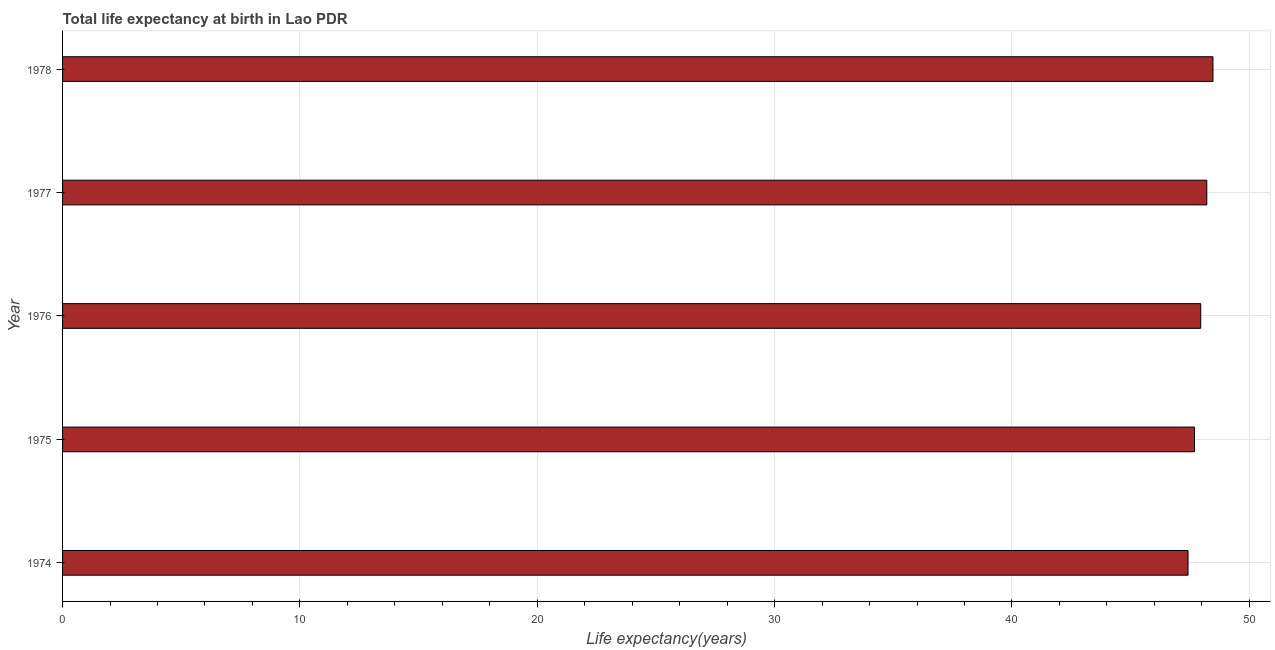What is the title of the graph?
Offer a very short reply. Total life expectancy at birth in Lao PDR. What is the label or title of the X-axis?
Make the answer very short. Life expectancy(years). What is the label or title of the Y-axis?
Your answer should be compact. Year. What is the life expectancy at birth in 1978?
Make the answer very short. 48.47. Across all years, what is the maximum life expectancy at birth?
Ensure brevity in your answer.  48.47. Across all years, what is the minimum life expectancy at birth?
Ensure brevity in your answer.  47.42. In which year was the life expectancy at birth maximum?
Your response must be concise. 1978. In which year was the life expectancy at birth minimum?
Provide a succinct answer. 1974. What is the sum of the life expectancy at birth?
Give a very brief answer. 239.73. What is the difference between the life expectancy at birth in 1974 and 1976?
Your response must be concise. -0.53. What is the average life expectancy at birth per year?
Offer a terse response. 47.95. What is the median life expectancy at birth?
Provide a short and direct response. 47.95. Is the life expectancy at birth in 1976 less than that in 1978?
Offer a terse response. Yes. Is the difference between the life expectancy at birth in 1976 and 1977 greater than the difference between any two years?
Your answer should be compact. No. What is the difference between the highest and the second highest life expectancy at birth?
Provide a short and direct response. 0.26. In how many years, is the life expectancy at birth greater than the average life expectancy at birth taken over all years?
Your answer should be very brief. 3. Are all the bars in the graph horizontal?
Offer a very short reply. Yes. How many years are there in the graph?
Make the answer very short. 5. Are the values on the major ticks of X-axis written in scientific E-notation?
Give a very brief answer. No. What is the Life expectancy(years) in 1974?
Offer a terse response. 47.42. What is the Life expectancy(years) of 1975?
Offer a terse response. 47.69. What is the Life expectancy(years) in 1976?
Offer a very short reply. 47.95. What is the Life expectancy(years) of 1977?
Your response must be concise. 48.21. What is the Life expectancy(years) in 1978?
Keep it short and to the point. 48.47. What is the difference between the Life expectancy(years) in 1974 and 1975?
Offer a terse response. -0.27. What is the difference between the Life expectancy(years) in 1974 and 1976?
Offer a terse response. -0.53. What is the difference between the Life expectancy(years) in 1974 and 1977?
Make the answer very short. -0.79. What is the difference between the Life expectancy(years) in 1974 and 1978?
Provide a short and direct response. -1.05. What is the difference between the Life expectancy(years) in 1975 and 1976?
Offer a terse response. -0.26. What is the difference between the Life expectancy(years) in 1975 and 1977?
Give a very brief answer. -0.52. What is the difference between the Life expectancy(years) in 1975 and 1978?
Keep it short and to the point. -0.78. What is the difference between the Life expectancy(years) in 1976 and 1977?
Give a very brief answer. -0.26. What is the difference between the Life expectancy(years) in 1976 and 1978?
Your response must be concise. -0.52. What is the difference between the Life expectancy(years) in 1977 and 1978?
Provide a succinct answer. -0.26. What is the ratio of the Life expectancy(years) in 1974 to that in 1976?
Make the answer very short. 0.99. What is the ratio of the Life expectancy(years) in 1974 to that in 1977?
Your answer should be very brief. 0.98. What is the ratio of the Life expectancy(years) in 1974 to that in 1978?
Keep it short and to the point. 0.98. What is the ratio of the Life expectancy(years) in 1975 to that in 1976?
Provide a succinct answer. 0.99. What is the ratio of the Life expectancy(years) in 1976 to that in 1978?
Ensure brevity in your answer.  0.99. What is the ratio of the Life expectancy(years) in 1977 to that in 1978?
Your response must be concise. 0.99. 